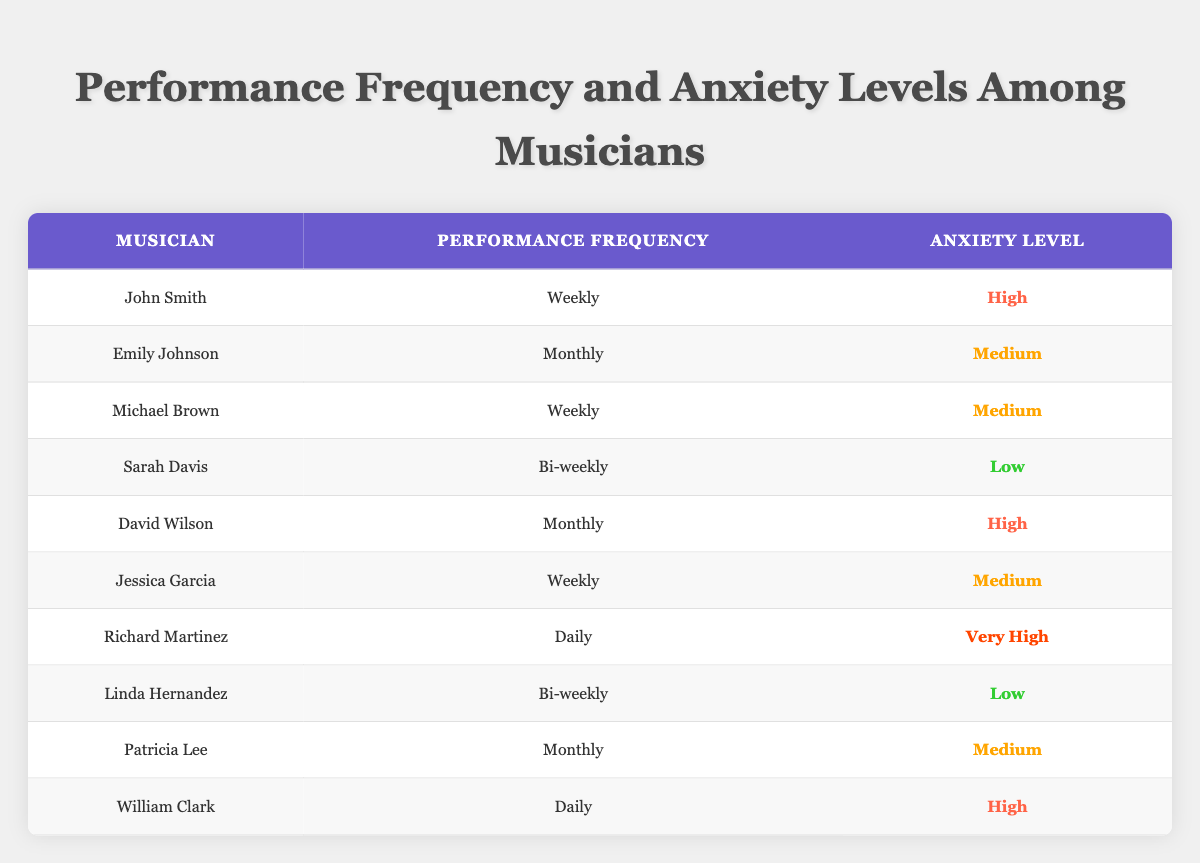What is the anxiety level of John Smith? John Smith's anxiety level is directly listed in the table under the corresponding row, which states "High"
Answer: High How many musicians perform weekly? By scanning the "Performance Frequency" column, there are three musicians (John Smith, Michael Brown, and Jessica Garcia) listed as performing "Weekly"
Answer: 3 Is there any musician with a "Very High" anxiety level who performs daily? Looking at the table, Richard Martinez has a "Very High" anxiety level and performs "Daily"
Answer: Yes Which performance frequency has the lowest average anxiety level? Examine the anxiety levels associated with each performance frequency: Weekly (High, Medium, Medium), Bi-weekly (Low, Low), and Monthly (High, Medium, Medium). The average levels are calculated, and Bi-weekly has the lowest average (Low)
Answer: Bi-weekly What is the anxiety level for the musician with the highest frequency of performance? Richard Martinez performs "Daily" and is listed with an anxiety level of "Very High," making him the musician with the highest frequency of performance and his corresponding anxiety level
Answer: Very High Are there more musicians with "Medium" anxiety levels than those with "High" anxiety levels? Count the musicians under the "Anxiety Level" column: "Medium" includes Emily Johnson, Michael Brown, Jessica Garcia, and Patricia Lee (4 total), while "High" includes John Smith, David Wilson, and William Clark (3 total). Since 4 is greater than 3, the answer is affirmative
Answer: Yes What would be the median anxiety level for musicians performing bi-weekly? The anxiety levels for Sarah Davis and Linda Hernandez (both performing Bi-weekly) are Low for both. Since there are two equal values, the median is Low
Answer: Low Which musician performs monthly and has a high anxiety level? Checking the "Performance Frequency" column for "Monthly" and looking at the corresponding anxiety level, David Wilson is the musician who fits this description
Answer: David Wilson 